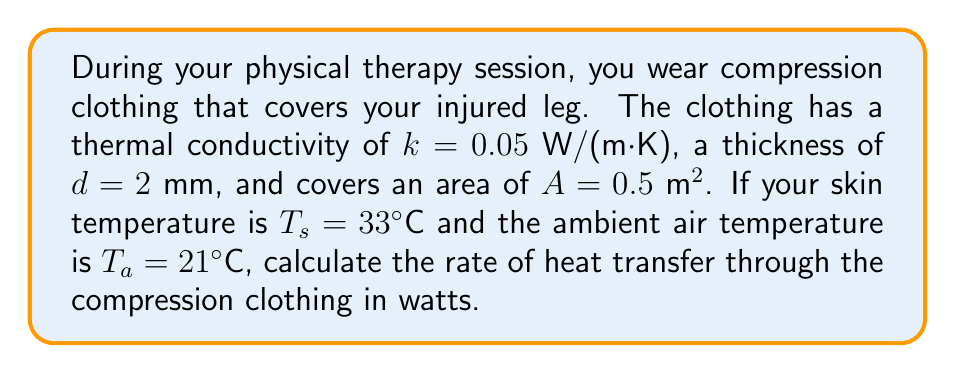What is the answer to this math problem? To solve this problem, we'll use Fourier's Law of Heat Conduction:

1) The equation for heat transfer rate is:
   $$Q = \frac{kA(T_s - T_a)}{d}$$

   Where:
   $Q$ = heat transfer rate (W)
   $k$ = thermal conductivity (W/(m·K))
   $A$ = area (m²)
   $T_s$ = skin temperature (°C)
   $T_a$ = ambient temperature (°C)
   $d$ = thickness of the material (m)

2) Let's substitute the given values:
   $k = 0.05$ W/(m·K)
   $A = 0.5$ m²
   $T_s = 33°C$
   $T_a = 21°C$
   $d = 2$ mm = $0.002$ m

3) Now, let's calculate:
   $$Q = \frac{0.05 \cdot 0.5 \cdot (33 - 21)}{0.002}$$

4) Simplify:
   $$Q = \frac{0.025 \cdot 12}{0.002} = \frac{0.3}{0.002} = 150$$

Therefore, the rate of heat transfer through the compression clothing is 150 W.
Answer: 150 W 